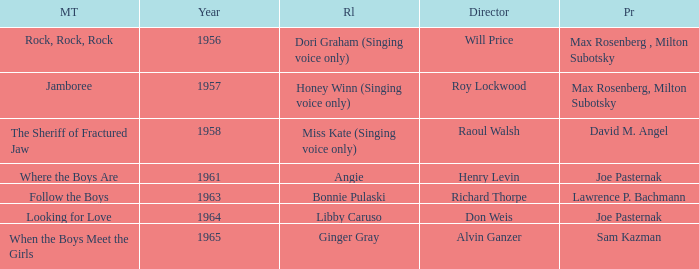What were the roles in 1961? Angie. Could you parse the entire table? {'header': ['MT', 'Year', 'Rl', 'Director', 'Pr'], 'rows': [['Rock, Rock, Rock', '1956', 'Dori Graham (Singing voice only)', 'Will Price', 'Max Rosenberg , Milton Subotsky'], ['Jamboree', '1957', 'Honey Winn (Singing voice only)', 'Roy Lockwood', 'Max Rosenberg, Milton Subotsky'], ['The Sheriff of Fractured Jaw', '1958', 'Miss Kate (Singing voice only)', 'Raoul Walsh', 'David M. Angel'], ['Where the Boys Are', '1961', 'Angie', 'Henry Levin', 'Joe Pasternak'], ['Follow the Boys', '1963', 'Bonnie Pulaski', 'Richard Thorpe', 'Lawrence P. Bachmann'], ['Looking for Love', '1964', 'Libby Caruso', 'Don Weis', 'Joe Pasternak'], ['When the Boys Meet the Girls', '1965', 'Ginger Gray', 'Alvin Ganzer', 'Sam Kazman']]} 